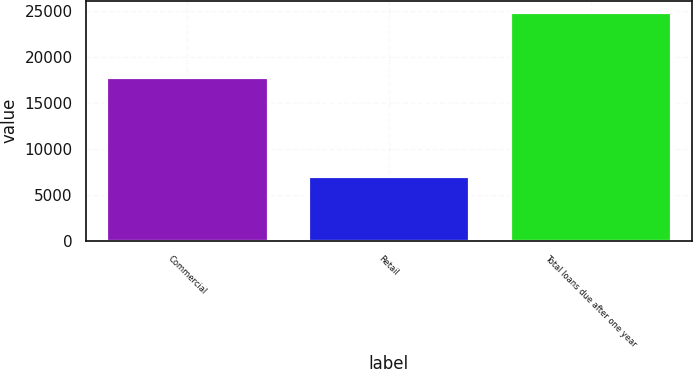Convert chart to OTSL. <chart><loc_0><loc_0><loc_500><loc_500><bar_chart><fcel>Commercial<fcel>Retail<fcel>Total loans due after one year<nl><fcel>17803.1<fcel>7060.5<fcel>24863.6<nl></chart> 